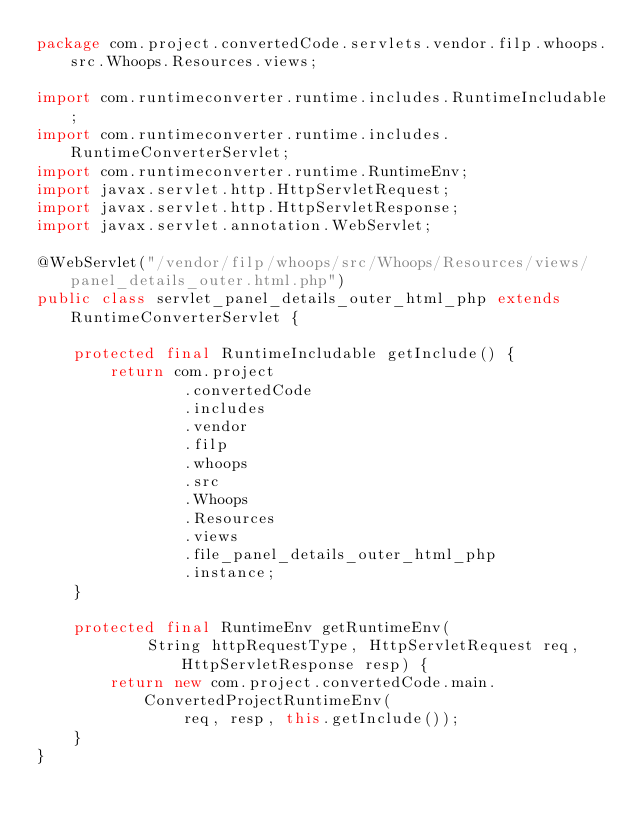<code> <loc_0><loc_0><loc_500><loc_500><_Java_>package com.project.convertedCode.servlets.vendor.filp.whoops.src.Whoops.Resources.views;

import com.runtimeconverter.runtime.includes.RuntimeIncludable;
import com.runtimeconverter.runtime.includes.RuntimeConverterServlet;
import com.runtimeconverter.runtime.RuntimeEnv;
import javax.servlet.http.HttpServletRequest;
import javax.servlet.http.HttpServletResponse;
import javax.servlet.annotation.WebServlet;

@WebServlet("/vendor/filp/whoops/src/Whoops/Resources/views/panel_details_outer.html.php")
public class servlet_panel_details_outer_html_php extends RuntimeConverterServlet {

    protected final RuntimeIncludable getInclude() {
        return com.project
                .convertedCode
                .includes
                .vendor
                .filp
                .whoops
                .src
                .Whoops
                .Resources
                .views
                .file_panel_details_outer_html_php
                .instance;
    }

    protected final RuntimeEnv getRuntimeEnv(
            String httpRequestType, HttpServletRequest req, HttpServletResponse resp) {
        return new com.project.convertedCode.main.ConvertedProjectRuntimeEnv(
                req, resp, this.getInclude());
    }
}
</code> 